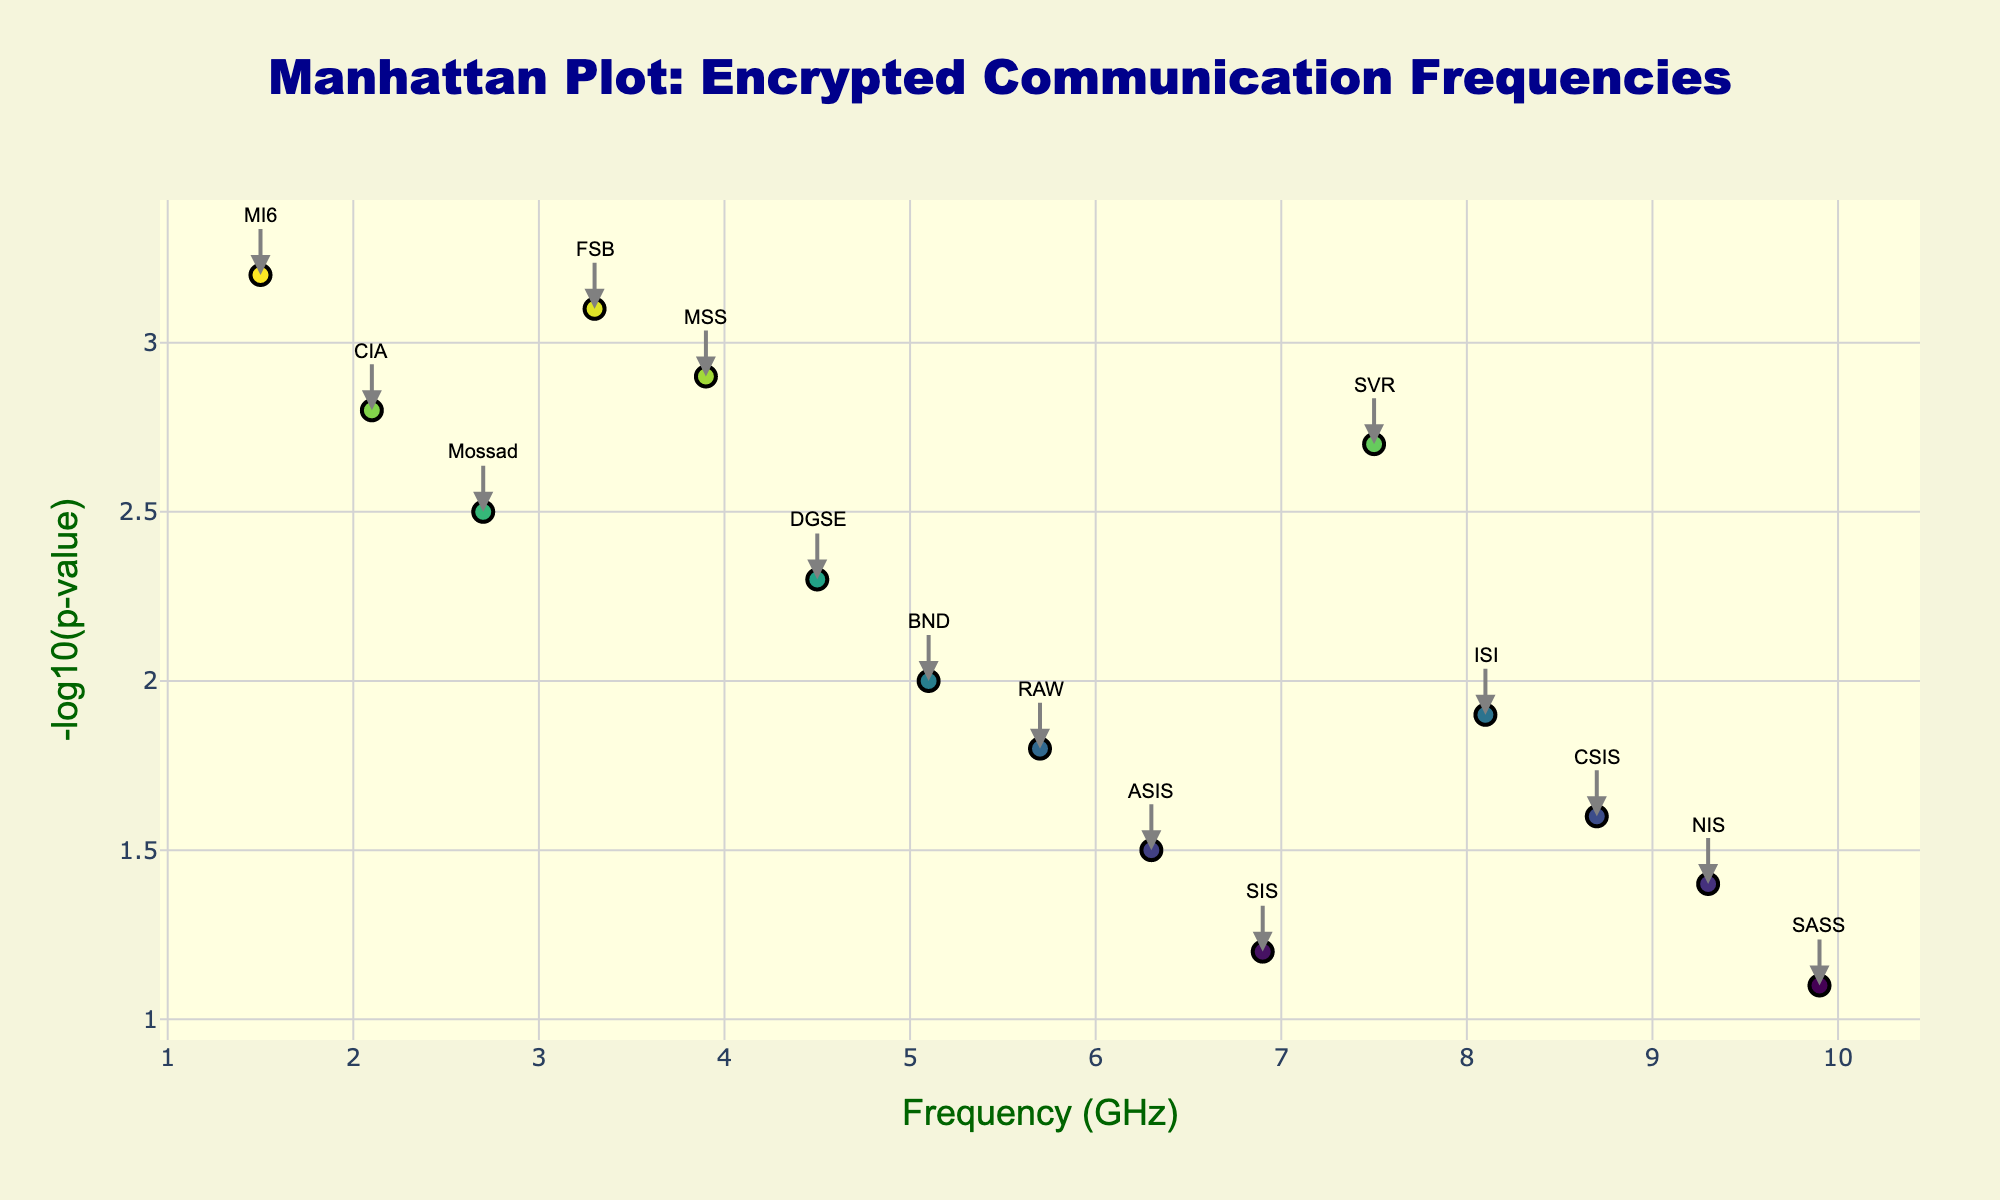What is the title of the plot? The title of the plot is displayed at the top-center of the figure. It reads "Manhattan Plot: Encrypted Communication Frequencies".
Answer: Manhattan Plot: Encrypted Communication Frequencies What is the x-axis label and what does it represent? The x-axis label is positioned below the x-axis and reads "Frequency (GHz)". It represents the frequency of the encrypted communication channels used by various spy networks measured in Gigahertz.
Answer: Frequency (GHz) How many data points are represented in the plot? Count the number of markers or annotations in the plot, which correspond to the data points given. There are 15 data points, each for a different spy network.
Answer: 15 Which spy network uses the highest frequency for encrypted communication? Locate the marker positioned farthest to the right on the x-axis. The network label for this marker indicates the spy network using the highest frequency (9.9 GHz). This is the SASS network.
Answer: SASS Which spy network has the highest -log10(p-value)? Identify the marker positioned highest on the y-axis since -log10(p-value) represents the y-axis value. The network label for this marker indicates the MI6 network with a value of 3.2.
Answer: MI6 Compare the frequencies used by MI6 and CIA. Which is higher and by how much? Locate the markers for MI6 and CIA on the x-axis. MI6 uses 1.5 GHz and CIA uses 2.1 GHz. Subtract MI6's frequency from CIA's: 2.1 - 1.5 = 0.6 GHz, so CIA is higher by 0.6 GHz.
Answer: CIA by 0.6 GHz What is the average frequency used by FSB, MSS, and DGSE networks? Find the frequencies for FSB (3.3 GHz), MSS (3.9 GHz), and DGSE (4.5 GHz). Calculate the average: (3.3 + 3.9 + 4.5) / 3 = 11.7 / 3 = 3.9 GHz.
Answer: 3.9 GHz Which network uses a frequency around the mid-range of frequencies despite having a relatively low -log10(p-value)? The mid-range of the frequencies given is around 5 GHz. The one with relatively low -log10(p-value) near this range is BND, with a frequency of 5.1 GHz and -log10(p-value) of 2.0.
Answer: BND Examine the data points between 4 GHz and 5 GHz. Which network is located in this range with the highest -log10(p-value)? Check the points within this range: MSS (3.9 GHz, 2.9) and DGSE (4.5 GHz, 2.3). MSS has the highest -log10(p-value) of 2.9.
Answer: MSS Are there any networks clustered together by frequency? If so, which networks? Look for data points that have close frequencies. Data points at 1.5 GHz (MI6), 2.1 GHz (CIA) are relatively close, also at 8.1 GHz (ISI) and 8.7 GHz (CSIS).
Answer: MI6 and CIA; ISI and CSIS 